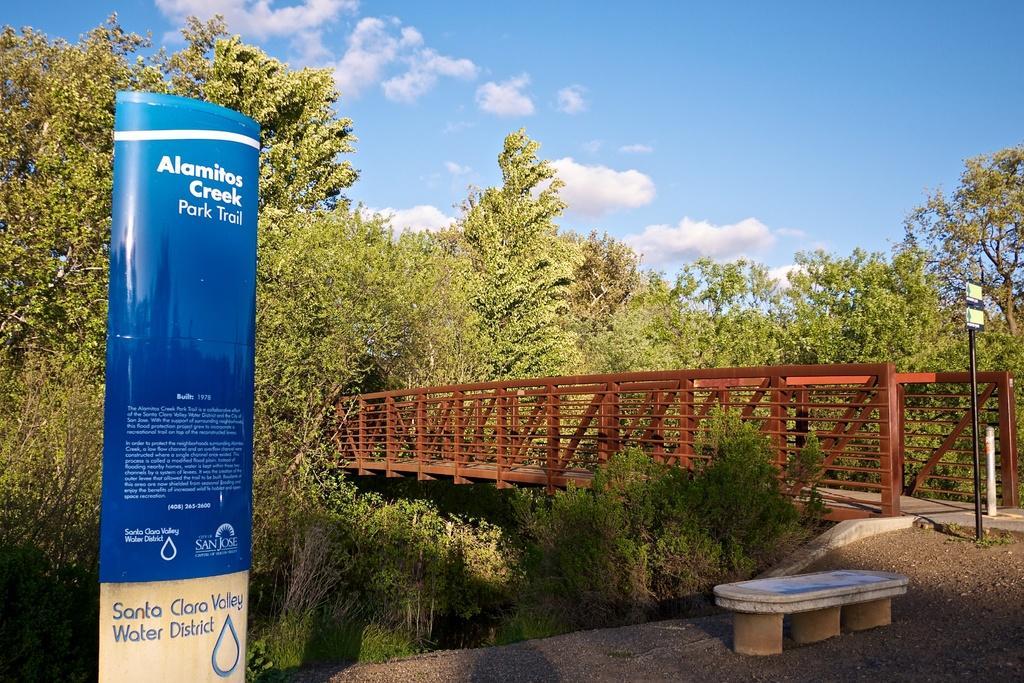Could you give a brief overview of what you see in this image? In this image we can see many trees, there is a bridge, there is a pole, there is a bench on the ground, there is a hoarding, the sky is cloudy. 